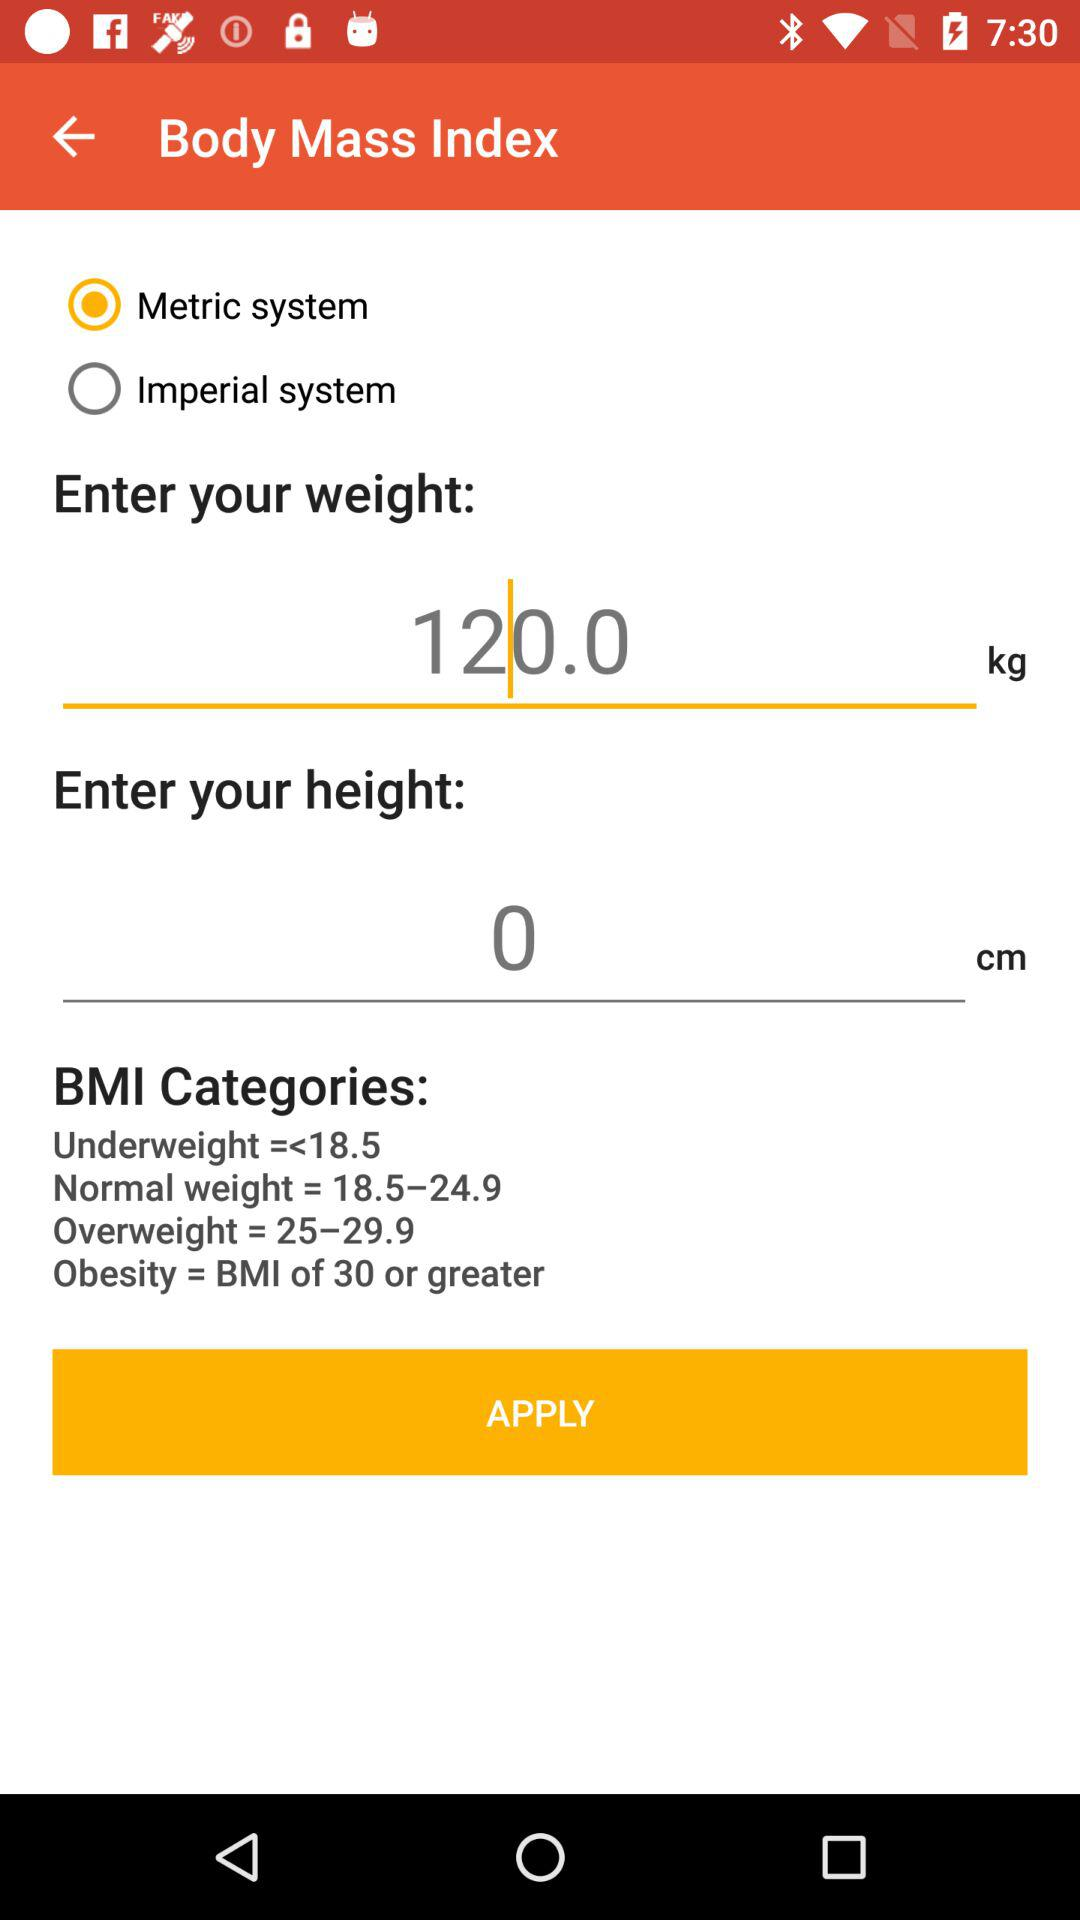What is the system used to measure BMI? To measure BMI, the metric system is used. 